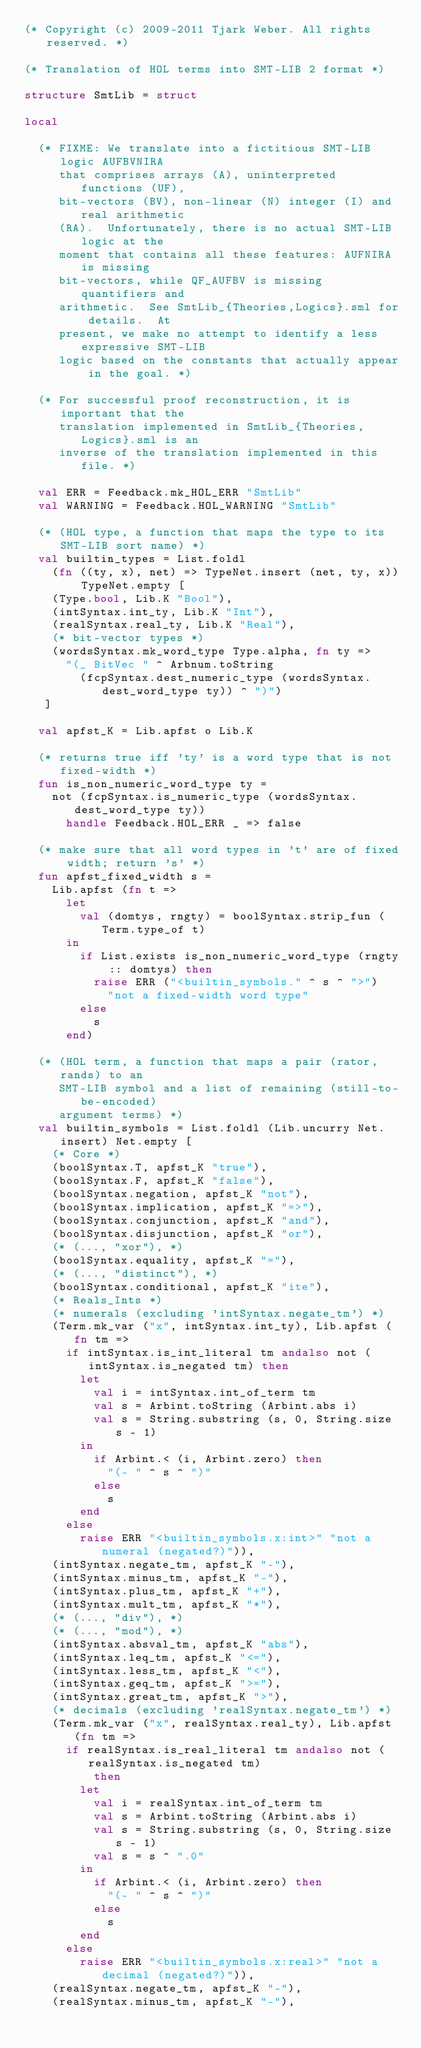<code> <loc_0><loc_0><loc_500><loc_500><_SML_>(* Copyright (c) 2009-2011 Tjark Weber. All rights reserved. *)

(* Translation of HOL terms into SMT-LIB 2 format *)

structure SmtLib = struct

local

  (* FIXME: We translate into a fictitious SMT-LIB logic AUFBVNIRA
     that comprises arrays (A), uninterpreted functions (UF),
     bit-vectors (BV), non-linear (N) integer (I) and real arithmetic
     (RA).  Unfortunately, there is no actual SMT-LIB logic at the
     moment that contains all these features: AUFNIRA is missing
     bit-vectors, while QF_AUFBV is missing quantifiers and
     arithmetic.  See SmtLib_{Theories,Logics}.sml for details.  At
     present, we make no attempt to identify a less expressive SMT-LIB
     logic based on the constants that actually appear in the goal. *)

  (* For successful proof reconstruction, it is important that the
     translation implemented in SmtLib_{Theories,Logics}.sml is an
     inverse of the translation implemented in this file. *)

  val ERR = Feedback.mk_HOL_ERR "SmtLib"
  val WARNING = Feedback.HOL_WARNING "SmtLib"

  (* (HOL type, a function that maps the type to its SMT-LIB sort name) *)
  val builtin_types = List.foldl
    (fn ((ty, x), net) => TypeNet.insert (net, ty, x)) TypeNet.empty [
    (Type.bool, Lib.K "Bool"),
    (intSyntax.int_ty, Lib.K "Int"),
    (realSyntax.real_ty, Lib.K "Real"),
    (* bit-vector types *)
    (wordsSyntax.mk_word_type Type.alpha, fn ty =>
      "(_ BitVec " ^ Arbnum.toString
        (fcpSyntax.dest_numeric_type (wordsSyntax.dest_word_type ty)) ^ ")")
   ]

  val apfst_K = Lib.apfst o Lib.K

  (* returns true iff 'ty' is a word type that is not fixed-width *)
  fun is_non_numeric_word_type ty =
    not (fcpSyntax.is_numeric_type (wordsSyntax.dest_word_type ty))
      handle Feedback.HOL_ERR _ => false

  (* make sure that all word types in 't' are of fixed width; return 's' *)
  fun apfst_fixed_width s =
    Lib.apfst (fn t =>
      let
        val (domtys, rngty) = boolSyntax.strip_fun (Term.type_of t)
      in
        if List.exists is_non_numeric_word_type (rngty :: domtys) then
          raise ERR ("<builtin_symbols." ^ s ^ ">")
            "not a fixed-width word type"
        else
          s
      end)

  (* (HOL term, a function that maps a pair (rator, rands) to an
     SMT-LIB symbol and a list of remaining (still-to-be-encoded)
     argument terms) *)
  val builtin_symbols = List.foldl (Lib.uncurry Net.insert) Net.empty [
    (* Core *)
    (boolSyntax.T, apfst_K "true"),
    (boolSyntax.F, apfst_K "false"),
    (boolSyntax.negation, apfst_K "not"),
    (boolSyntax.implication, apfst_K "=>"),
    (boolSyntax.conjunction, apfst_K "and"),
    (boolSyntax.disjunction, apfst_K "or"),
    (* (..., "xor"), *)
    (boolSyntax.equality, apfst_K "="),
    (* (..., "distinct"), *)
    (boolSyntax.conditional, apfst_K "ite"),
    (* Reals_Ints *)
    (* numerals (excluding 'intSyntax.negate_tm') *)
    (Term.mk_var ("x", intSyntax.int_ty), Lib.apfst (fn tm =>
      if intSyntax.is_int_literal tm andalso not (intSyntax.is_negated tm) then
        let
          val i = intSyntax.int_of_term tm
          val s = Arbint.toString (Arbint.abs i)
          val s = String.substring (s, 0, String.size s - 1)
        in
          if Arbint.< (i, Arbint.zero) then
            "(- " ^ s ^ ")"
          else
            s
        end
      else
        raise ERR "<builtin_symbols.x:int>" "not a numeral (negated?)")),
    (intSyntax.negate_tm, apfst_K "-"),
    (intSyntax.minus_tm, apfst_K "-"),
    (intSyntax.plus_tm, apfst_K "+"),
    (intSyntax.mult_tm, apfst_K "*"),
    (* (..., "div"), *)
    (* (..., "mod"), *)
    (intSyntax.absval_tm, apfst_K "abs"),
    (intSyntax.leq_tm, apfst_K "<="),
    (intSyntax.less_tm, apfst_K "<"),
    (intSyntax.geq_tm, apfst_K ">="),
    (intSyntax.great_tm, apfst_K ">"),
    (* decimals (excluding 'realSyntax.negate_tm') *)
    (Term.mk_var ("x", realSyntax.real_ty), Lib.apfst (fn tm =>
      if realSyntax.is_real_literal tm andalso not (realSyntax.is_negated tm)
          then
        let
          val i = realSyntax.int_of_term tm
          val s = Arbint.toString (Arbint.abs i)
          val s = String.substring (s, 0, String.size s - 1)
          val s = s ^ ".0"
        in
          if Arbint.< (i, Arbint.zero) then
            "(- " ^ s ^ ")"
          else
            s
        end
      else
        raise ERR "<builtin_symbols.x:real>" "not a decimal (negated?)")),
    (realSyntax.negate_tm, apfst_K "-"),
    (realSyntax.minus_tm, apfst_K "-"),</code> 